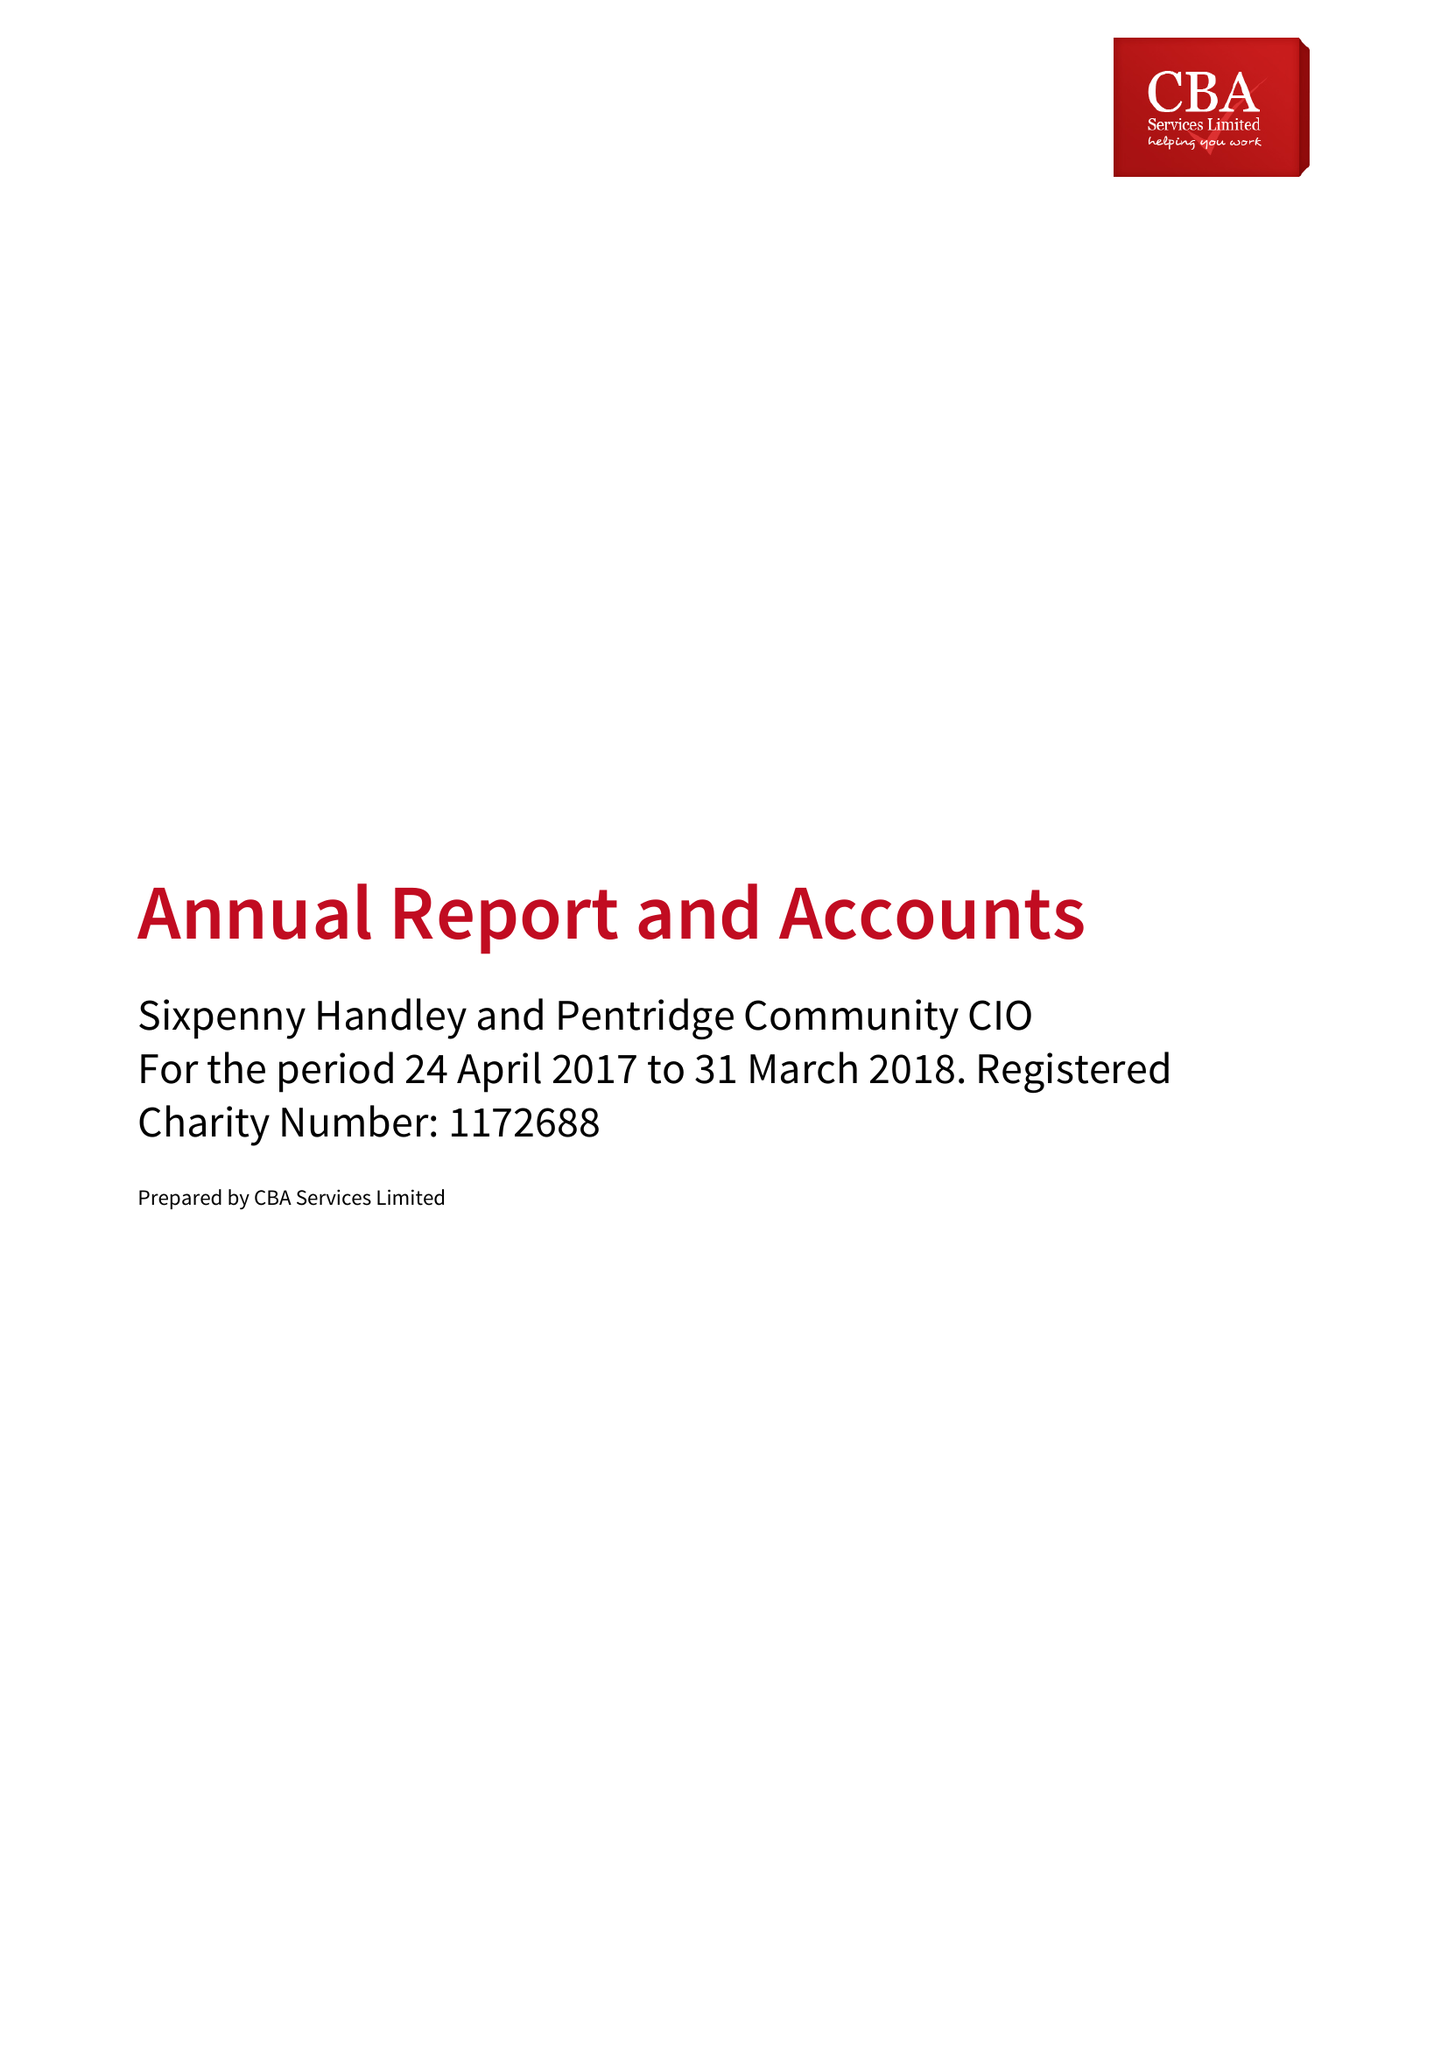What is the value for the income_annually_in_british_pounds?
Answer the question using a single word or phrase. 13473.00 